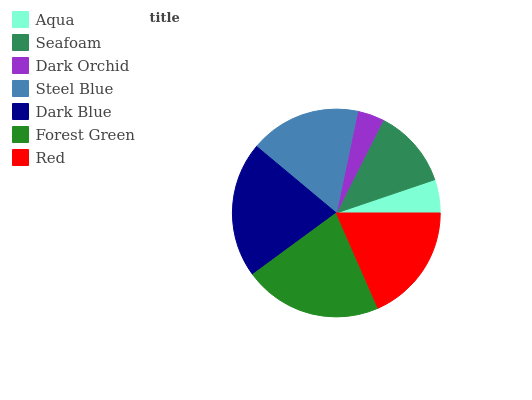Is Dark Orchid the minimum?
Answer yes or no. Yes. Is Forest Green the maximum?
Answer yes or no. Yes. Is Seafoam the minimum?
Answer yes or no. No. Is Seafoam the maximum?
Answer yes or no. No. Is Seafoam greater than Aqua?
Answer yes or no. Yes. Is Aqua less than Seafoam?
Answer yes or no. Yes. Is Aqua greater than Seafoam?
Answer yes or no. No. Is Seafoam less than Aqua?
Answer yes or no. No. Is Steel Blue the high median?
Answer yes or no. Yes. Is Steel Blue the low median?
Answer yes or no. Yes. Is Dark Orchid the high median?
Answer yes or no. No. Is Dark Orchid the low median?
Answer yes or no. No. 